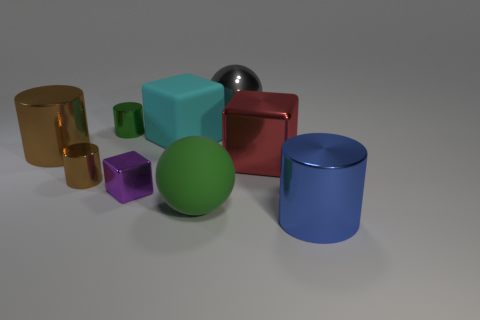How big is the shiny cylinder that is both in front of the large metallic cube and behind the big green matte object?
Make the answer very short. Small. How many other cylinders are the same size as the blue cylinder?
Provide a succinct answer. 1. There is a red object that is the same shape as the purple metal object; what is its material?
Provide a succinct answer. Metal. Do the cyan rubber thing and the large red thing have the same shape?
Provide a succinct answer. Yes. There is a large cyan rubber cube; what number of large cyan rubber cubes are to the right of it?
Your answer should be very brief. 0. What is the shape of the big shiny object behind the large metallic thing on the left side of the big green object?
Offer a very short reply. Sphere. There is a red object that is made of the same material as the gray thing; what is its shape?
Ensure brevity in your answer.  Cube. There is a brown cylinder that is left of the tiny brown shiny cylinder; is its size the same as the green thing that is behind the large metal block?
Keep it short and to the point. No. There is a rubber thing that is to the right of the large cyan matte object; what shape is it?
Provide a short and direct response. Sphere. The big matte block is what color?
Ensure brevity in your answer.  Cyan. 